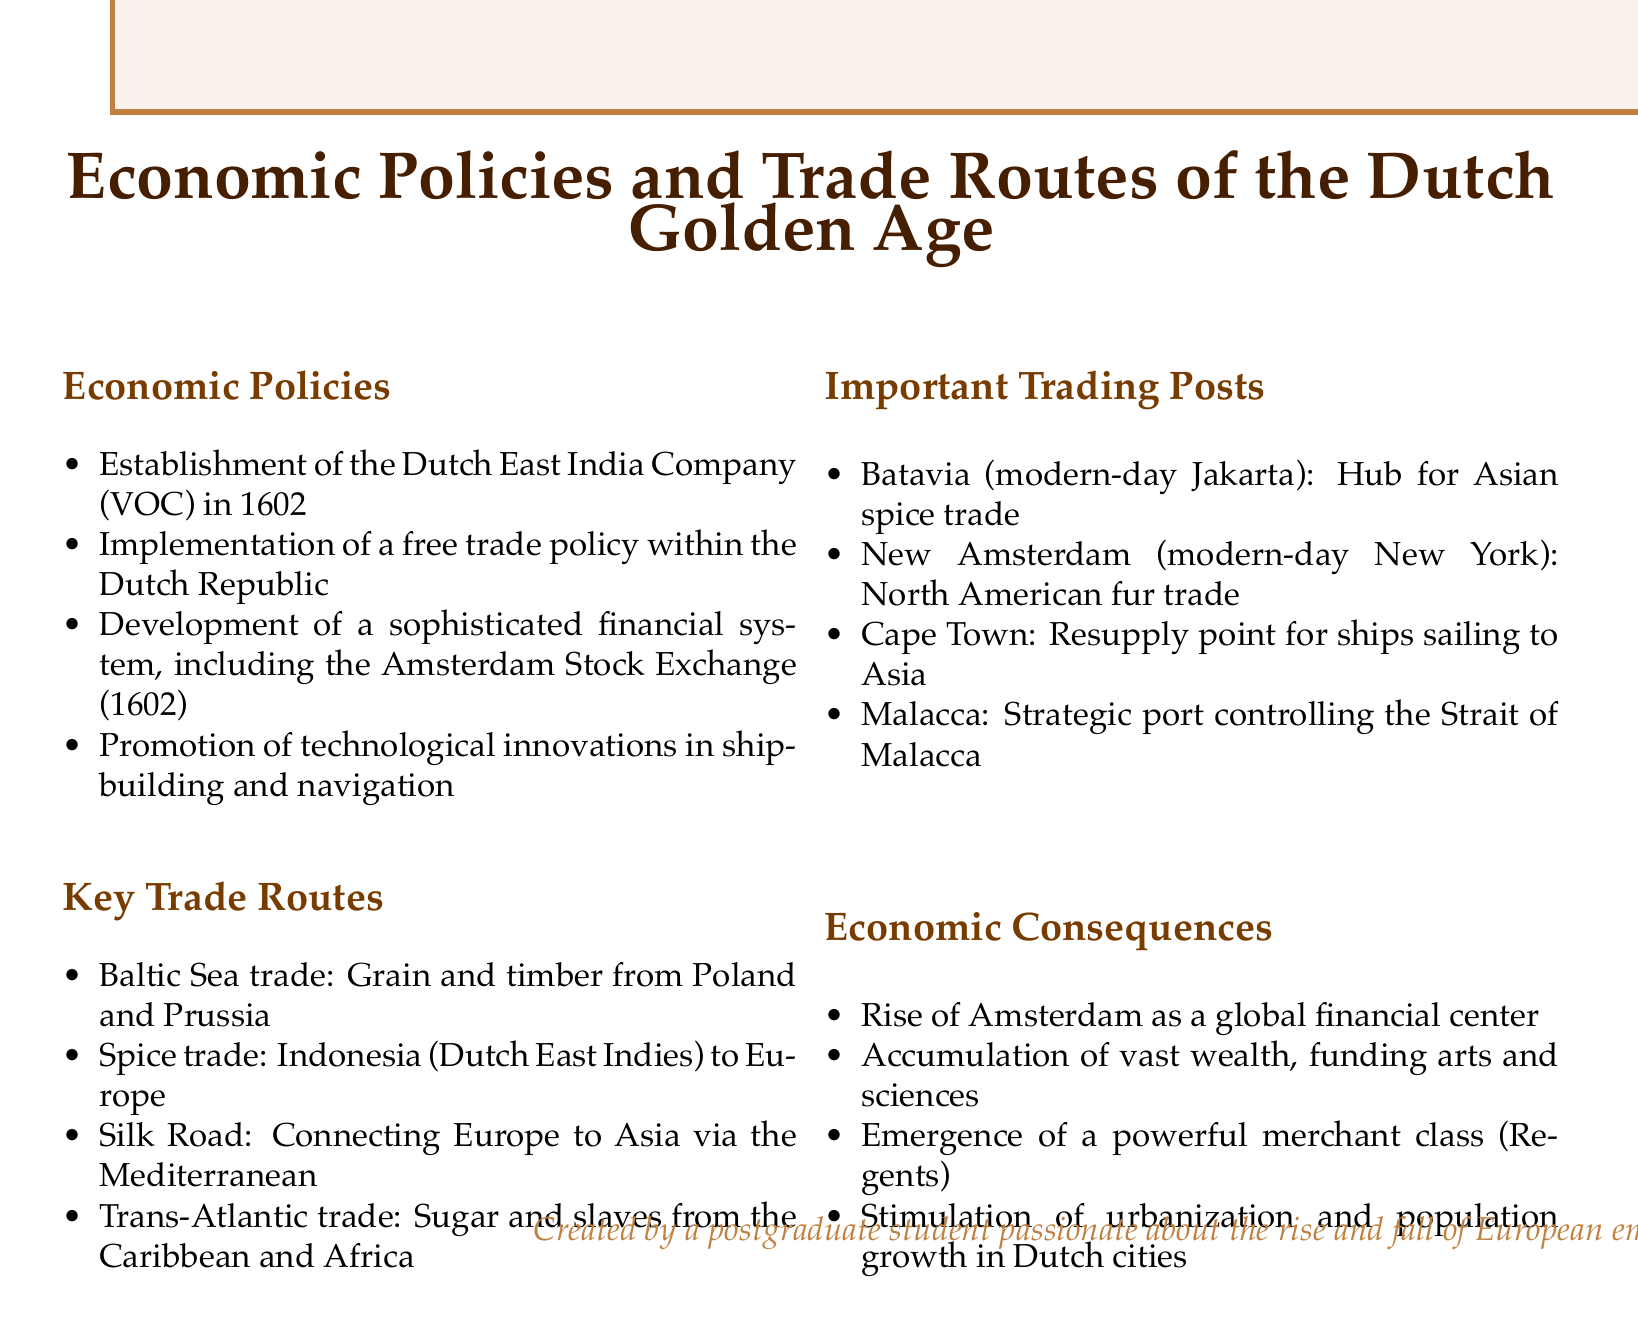What was established in 1602? The document states that the Dutch East India Company (VOC) was established in 1602.
Answer: Dutch East India Company (VOC) What is the primary financial institution mentioned? The document mentions the development of the Amsterdam Stock Exchange in 1602 as a key financial institution.
Answer: Amsterdam Stock Exchange What type of trade was conducted from the Caribbean and Africa? The document specifies that the Trans-Atlantic trade involved sugar and slaves from the Caribbean and Africa.
Answer: Sugar and slaves Which city rose as a global financial center? According to the document, Amsterdam emerged as the global financial center during the Dutch Golden Age.
Answer: Amsterdam What was the purpose of Batavia? The document describes Batavia as a hub for the Asian spice trade.
Answer: Hub for Asian spice trade How did the VOC contribute to trade? The establishment of the VOC facilitated the spice trade from Indonesia to Europe, influencing global trade patterns.
Answer: Spice trade Which trading post was a resupply point for ships sailing to Asia? The document states that Cape Town served as a resupply point for ships heading to Asia.
Answer: Cape Town What was a consequence of urbanization in Dutch cities? The document notes that urbanization in Dutch cities stimulated population growth.
Answer: Population growth 